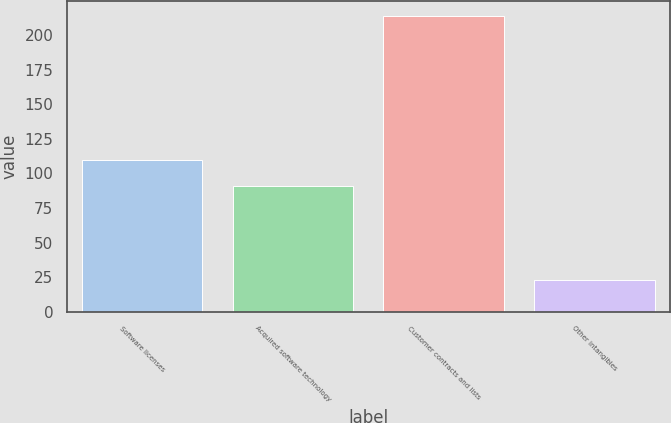Convert chart to OTSL. <chart><loc_0><loc_0><loc_500><loc_500><bar_chart><fcel>Software licenses<fcel>Acquired software technology<fcel>Customer contracts and lists<fcel>Other intangibles<nl><fcel>110.1<fcel>91<fcel>213.9<fcel>23<nl></chart> 